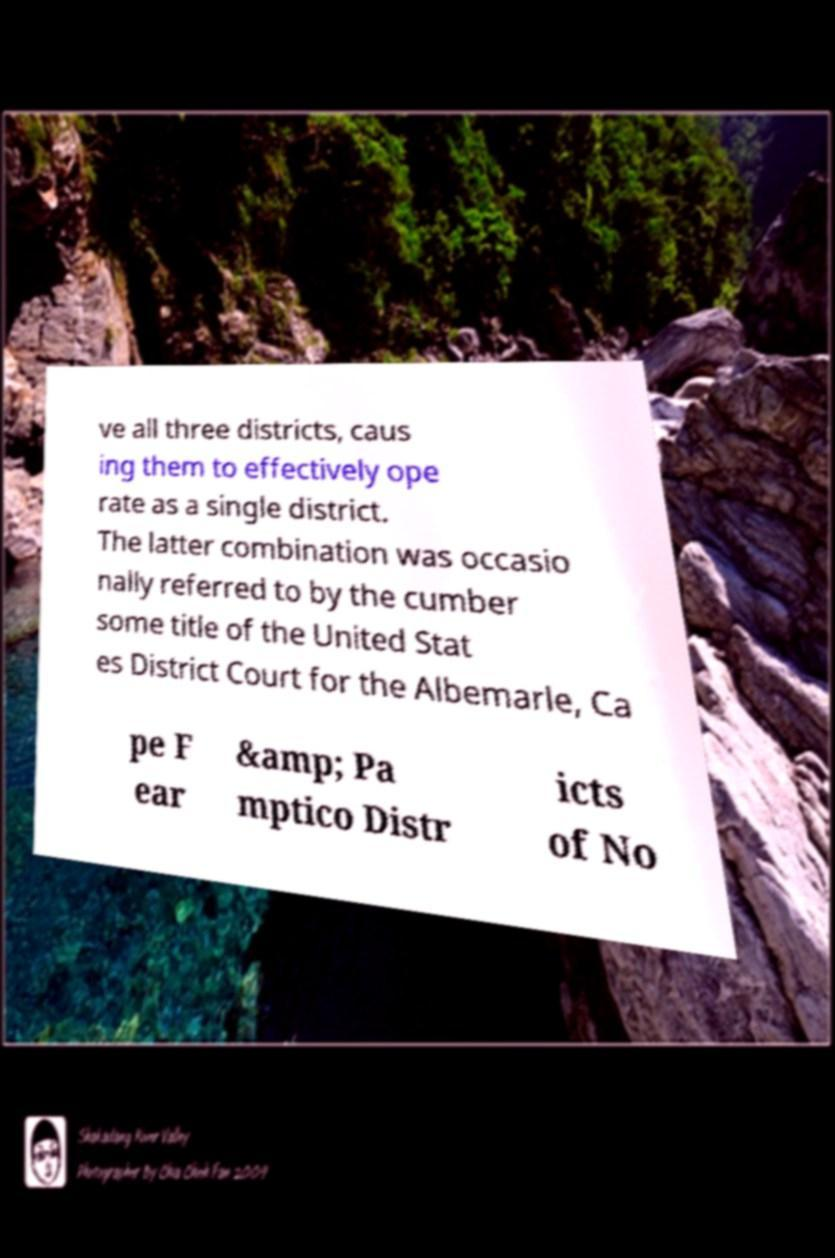Can you read and provide the text displayed in the image?This photo seems to have some interesting text. Can you extract and type it out for me? ve all three districts, caus ing them to effectively ope rate as a single district. The latter combination was occasio nally referred to by the cumber some title of the United Stat es District Court for the Albemarle, Ca pe F ear &amp; Pa mptico Distr icts of No 